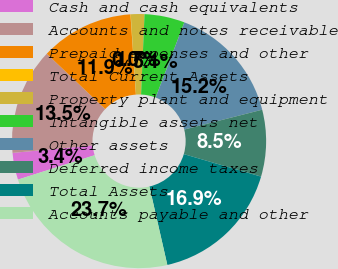<chart> <loc_0><loc_0><loc_500><loc_500><pie_chart><fcel>Cash and cash equivalents<fcel>Accounts and notes receivable<fcel>Prepaid expenses and other<fcel>Total Current Assets<fcel>Property plant and equipment<fcel>Intangible assets net<fcel>Other assets<fcel>Deferred income taxes<fcel>Total Assets<fcel>Accounts payable and other<nl><fcel>3.42%<fcel>13.54%<fcel>11.86%<fcel>0.04%<fcel>1.73%<fcel>5.11%<fcel>15.23%<fcel>8.48%<fcel>16.92%<fcel>23.67%<nl></chart> 